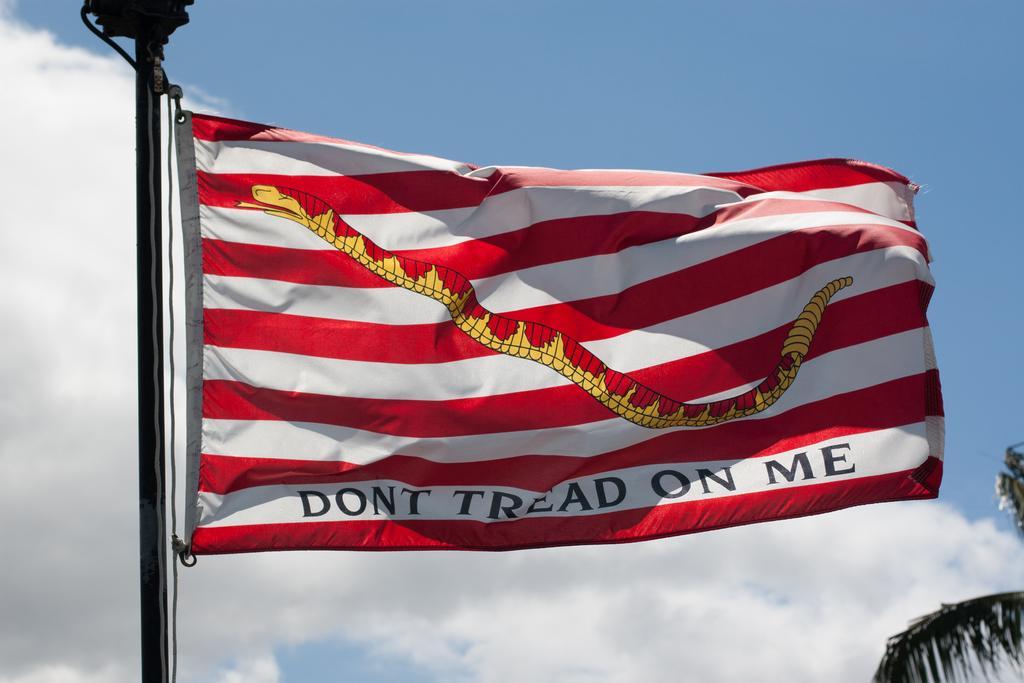Describe this image in one or two sentences. In this image we can see the flag with some text on it and there is a tree and in the background, we can see the sky with clouds. 